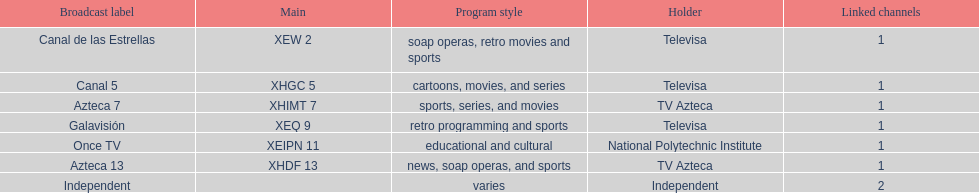What is the average number of affiliates that a given network will have? 1. 